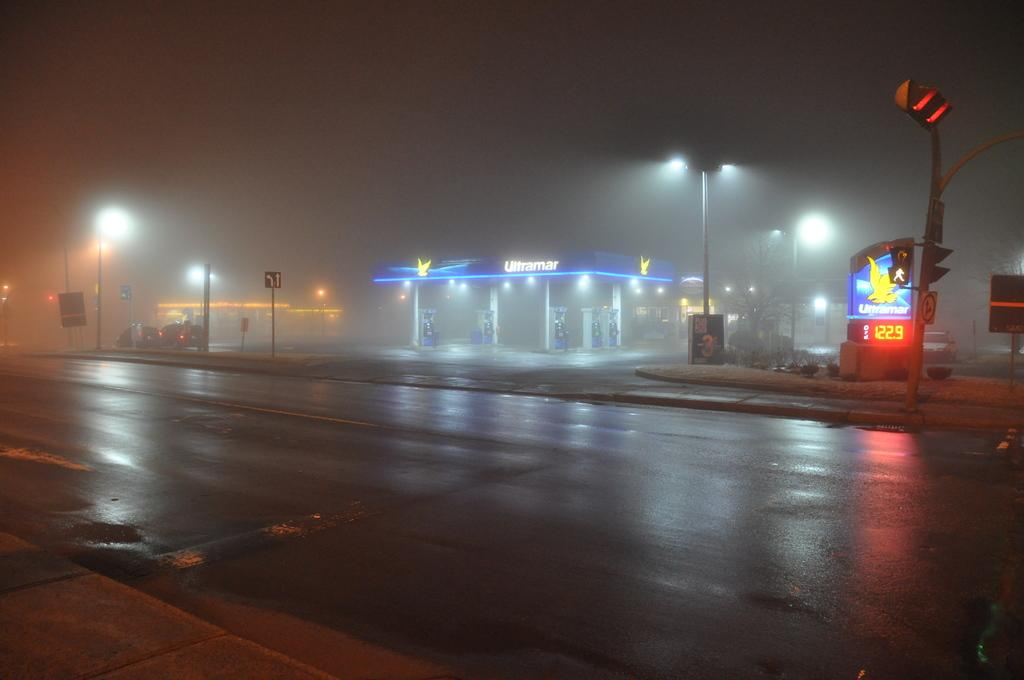What type of establishment is shown in the image? There is a fuel station in the image. What other objects can be seen near the fuel station? Street poles are present in the image. Is there any traffic control device visible in the image? Yes, there is a signal pole beside the road. What can be seen in the background of the image? The sky is visible at the top of the image. What type of border is present between the fuel station and the street? There is no specific border mentioned or visible in the image between the fuel station and the street. 